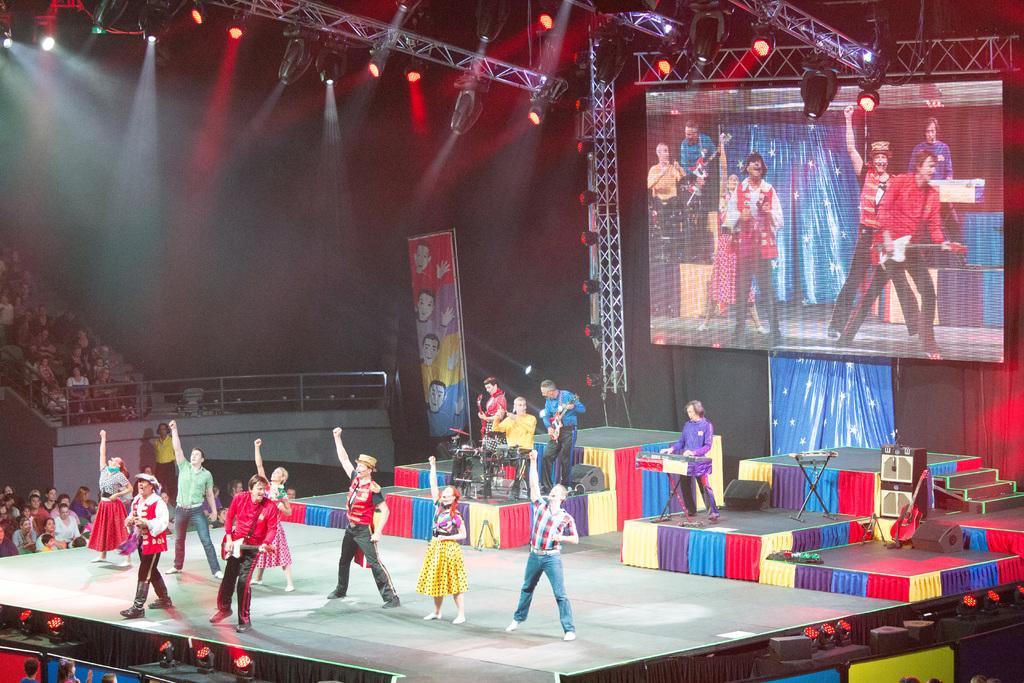Please provide a concise description of this image. In the picture we can see a stage on it, we can see some people are dancing and behind it, we can see some people are playing a musical instrument and behind them, we can see a screen and images of the people are dancing on it and to the ceiling we can see the rods and focus lights on it and under it we can see some people are sitting on the chairs near the railing. 